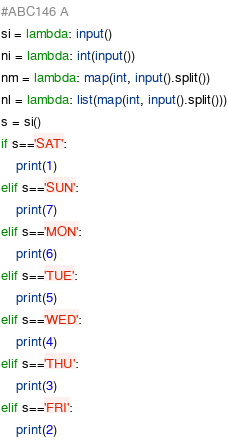<code> <loc_0><loc_0><loc_500><loc_500><_Python_>#ABC146 A
si = lambda: input()
ni = lambda: int(input())
nm = lambda: map(int, input().split())
nl = lambda: list(map(int, input().split()))
s = si()
if s=='SAT':
    print(1)
elif s=='SUN':
    print(7)
elif s=='MON':
    print(6)
elif s=='TUE':
    print(5)
elif s=='WED':
    print(4)
elif s=='THU':
    print(3)
elif s=='FRI':
    print(2)

</code> 